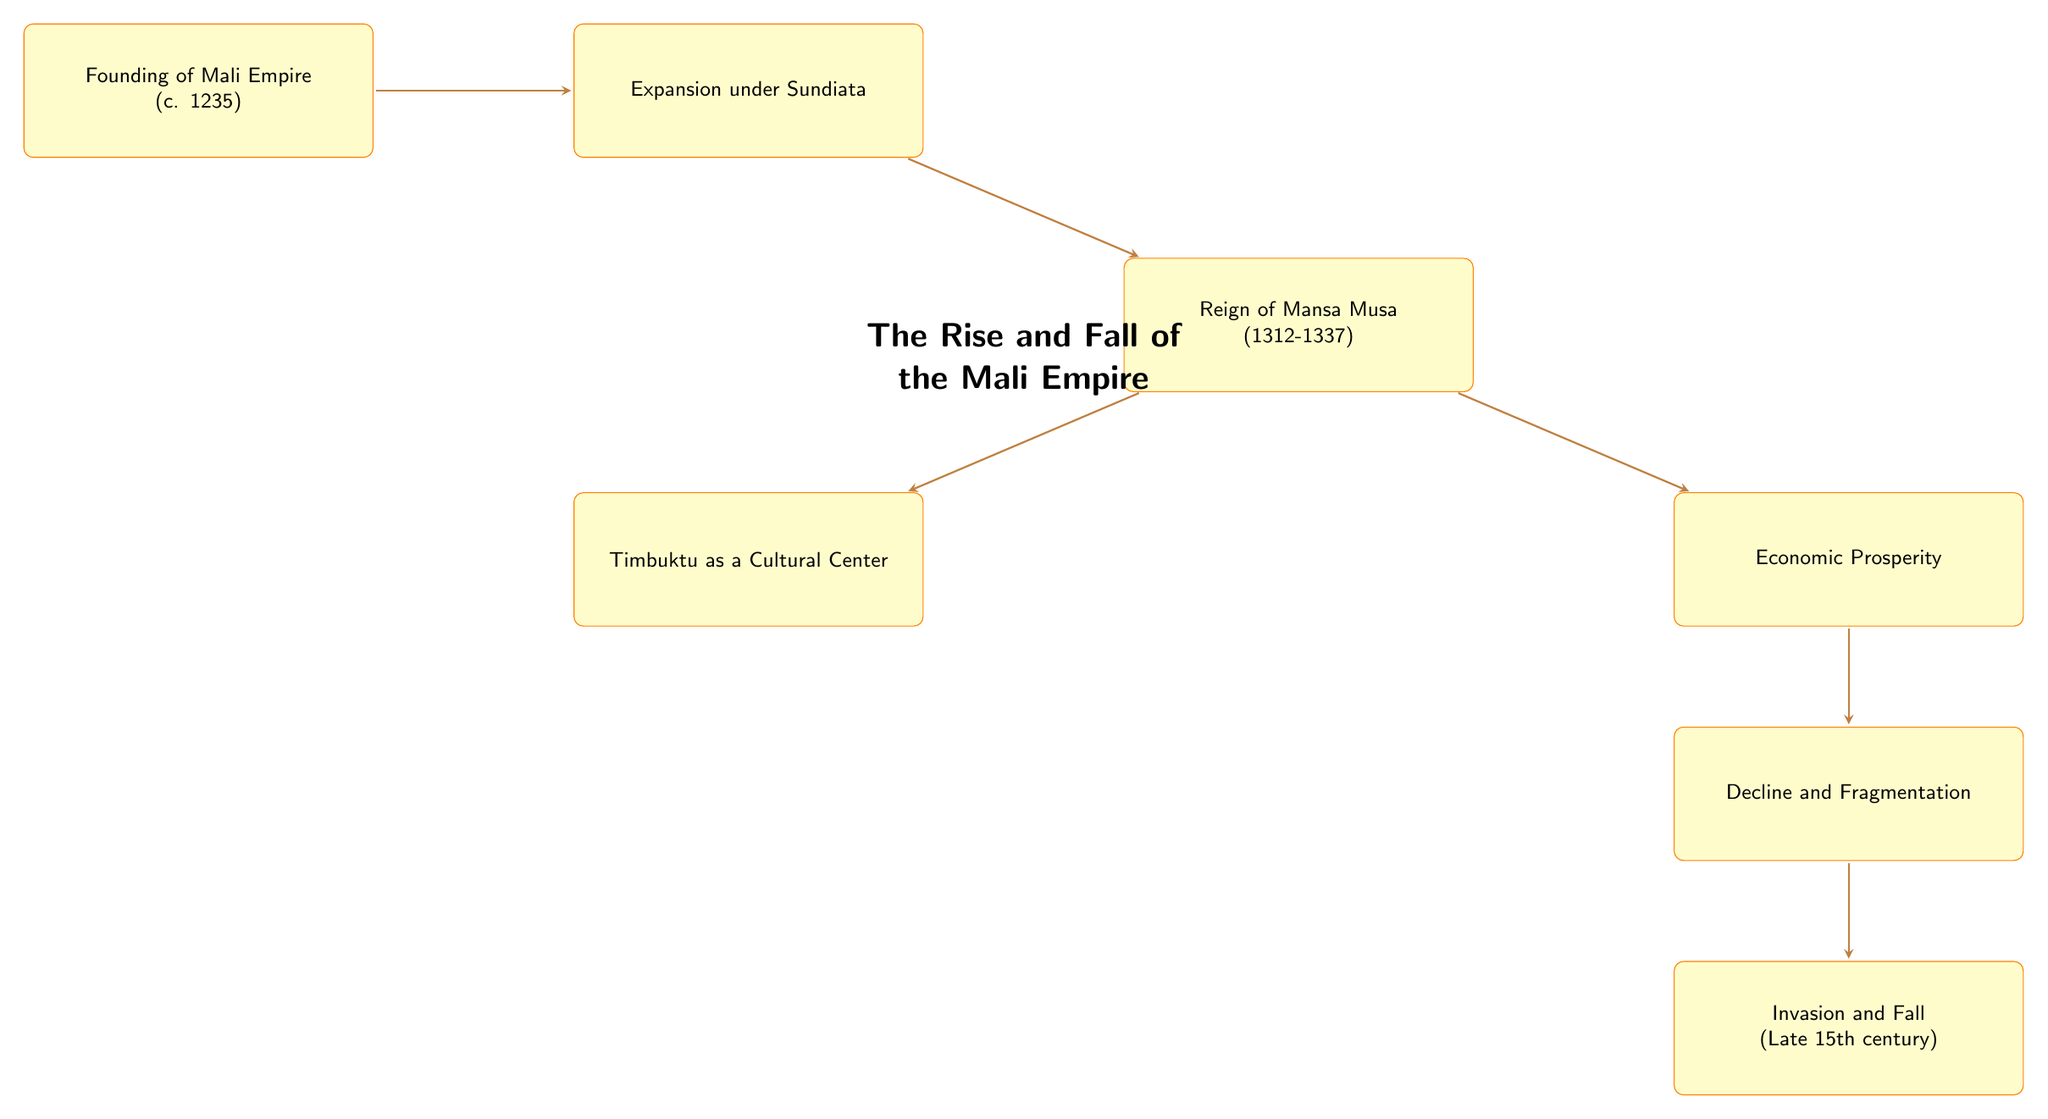What is the earliest event in the timeline? The diagram indicates the earliest event is the "Founding of Mali Empire," denoted by the first node.
Answer: Founding of Mali Empire What significant economic activity contributed to the Mali Empire's wealth? The diagram shows that "Gold and salt trade" was a primary factor for "Economic Prosperity," which highlights its impact on the empire's wealth.
Answer: Gold and salt trade Which ruler's reign is associated with the peak of the Mali Empire? According to the diagram, the "Reign of Mansa Musa" is identified as a significant period for the empire, marking its height.
Answer: Mansa Musa How many nodes illustrate events leading to the decline of the Mali Empire? The diagram displays three nodes relevant to the decline: "Decline and Fragmentation," and "Invasion and Fall". Counting these provides the answer.
Answer: 2 What role did Timbuktu play during the empire's height? The diagram specifies that "Timbuktu as a Cultural Center" thrived during the "Reign of Mansa Musa," indicating its importance to the empire.
Answer: Cultural Center What led to the fall of the Mali Empire? The flow diagram connects the "Decline and Fragmentation" to "Invasion and Fall," indicating that the invasions were a direct consequence of the decline.
Answer: Invasion What immediate event followed the expansion under Sundiata? Following "Expansion under Sundiata," the diagram links directly to "Reign of Mansa Musa," showing the timeline of events that followed.
Answer: Reign of Mansa Musa How does economic prosperity connect to the Mali Empire's decline? The diagram illustrates that "Economic Prosperity" leads to "Decline and Fragmentation," suggesting that a change in prosperity was integral to the subsequent decline.
Answer: Economic Prosperity Which event is described as occurring in the late 15th century? The diagram specifically notes "Invasion and Fall" occurs in the "Late 15th century," marking an important chronological point.
Answer: Late 15th century 